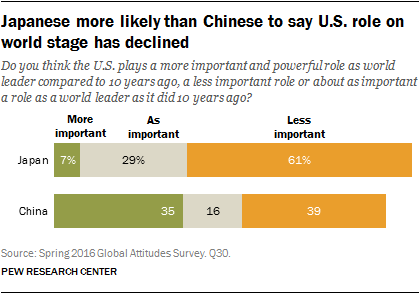Indicate a few pertinent items in this graphic. The difference in value between more important and as important in China is 19... In Japan, the color that represents 29% is gray. 